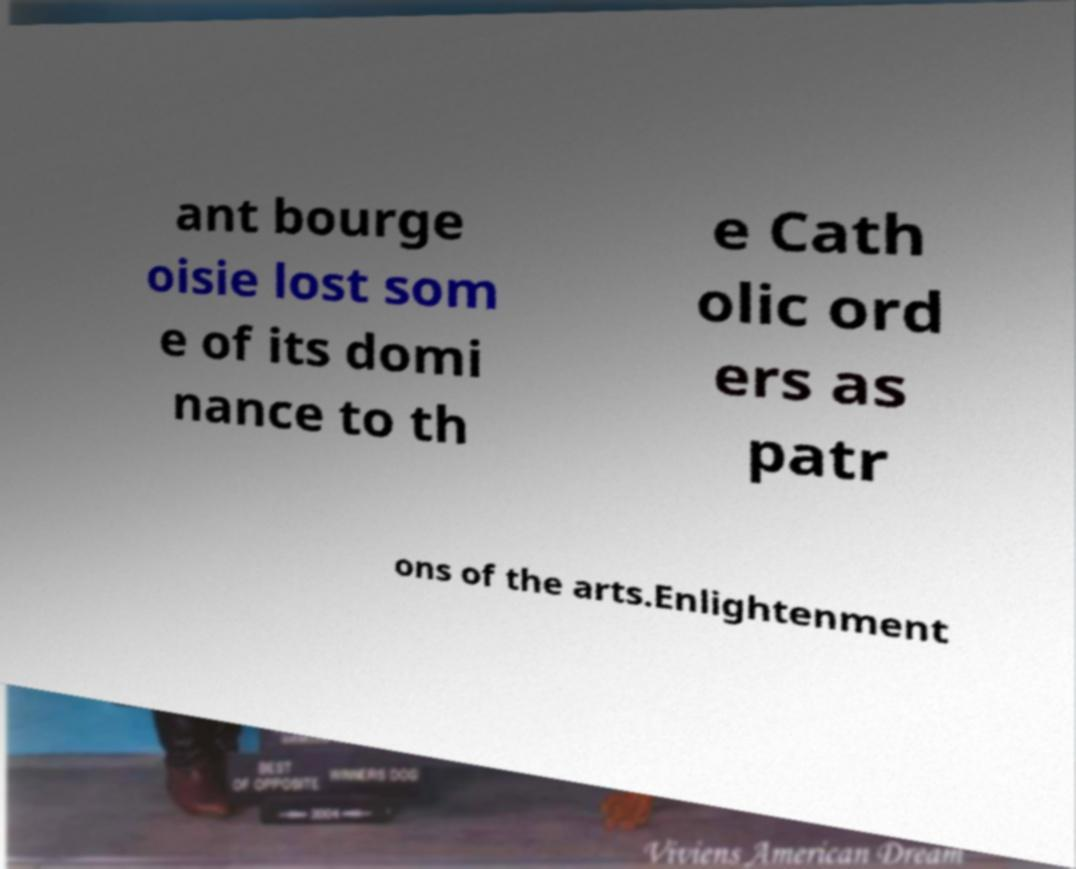Please read and relay the text visible in this image. What does it say? ant bourge oisie lost som e of its domi nance to th e Cath olic ord ers as patr ons of the arts.Enlightenment 